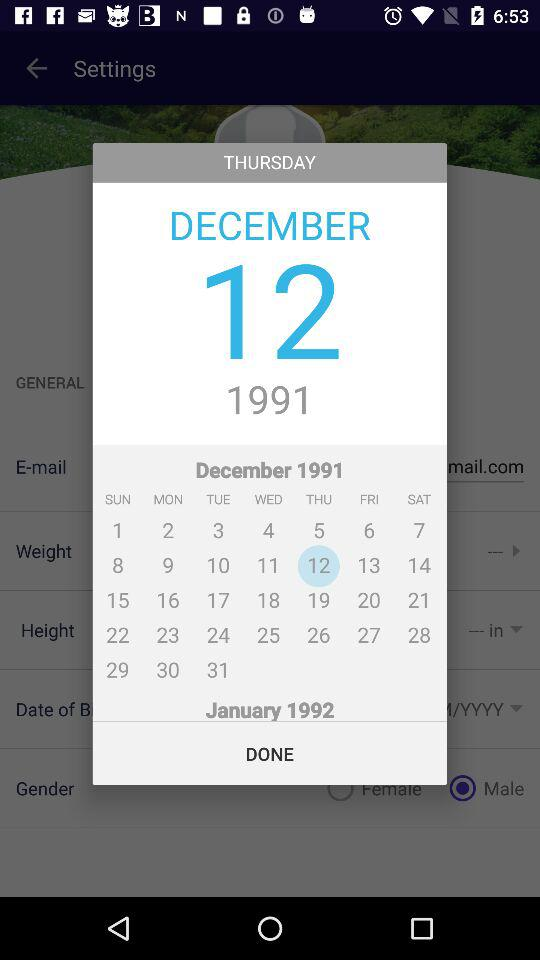What is the day on 12 December, 1991? The day is Thursday. 